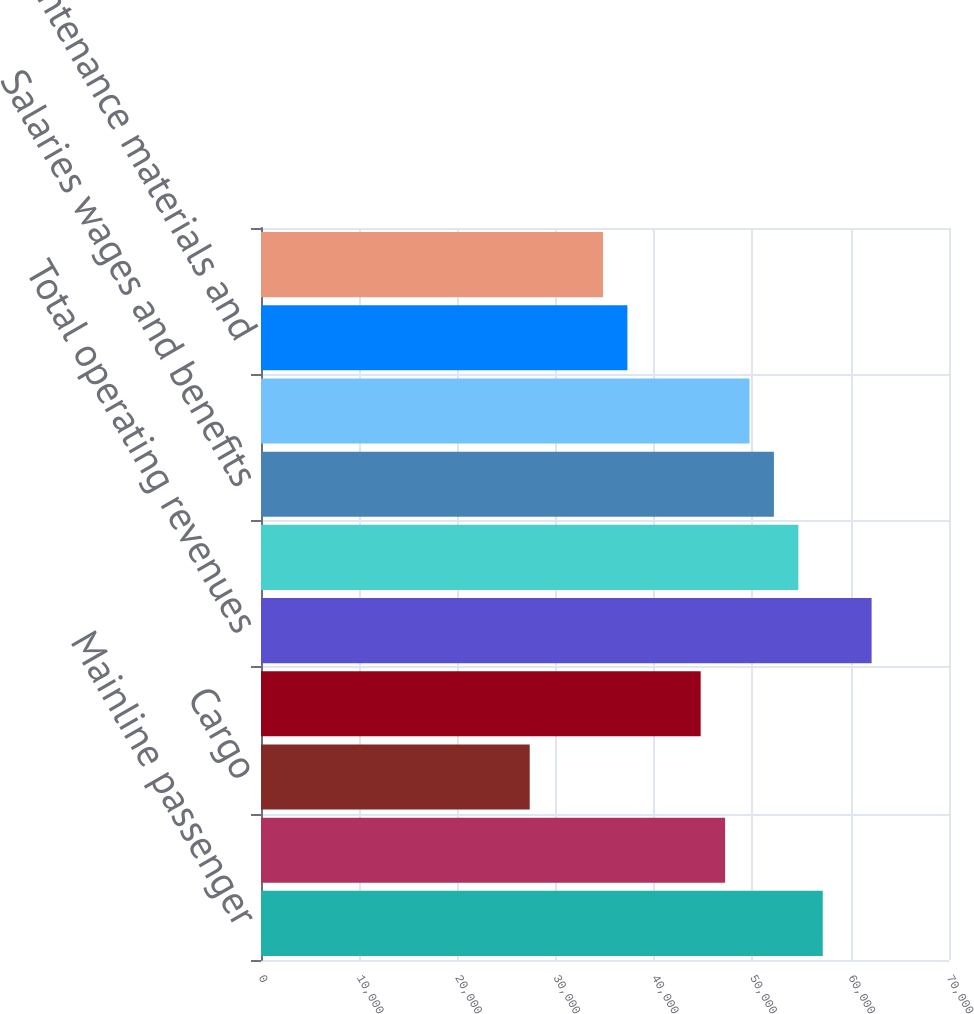Convert chart to OTSL. <chart><loc_0><loc_0><loc_500><loc_500><bar_chart><fcel>Mainline passenger<fcel>Regional passenger<fcel>Cargo<fcel>Other<fcel>Total operating revenues<fcel>Aircraft fuel and related<fcel>Salaries wages and benefits<fcel>Regional expenses<fcel>Maintenance materials and<fcel>Other rent and landing fees<nl><fcel>57156.8<fcel>47217.8<fcel>27339.8<fcel>44733<fcel>62126.3<fcel>54672<fcel>52187.3<fcel>49702.5<fcel>37278.8<fcel>34794<nl></chart> 